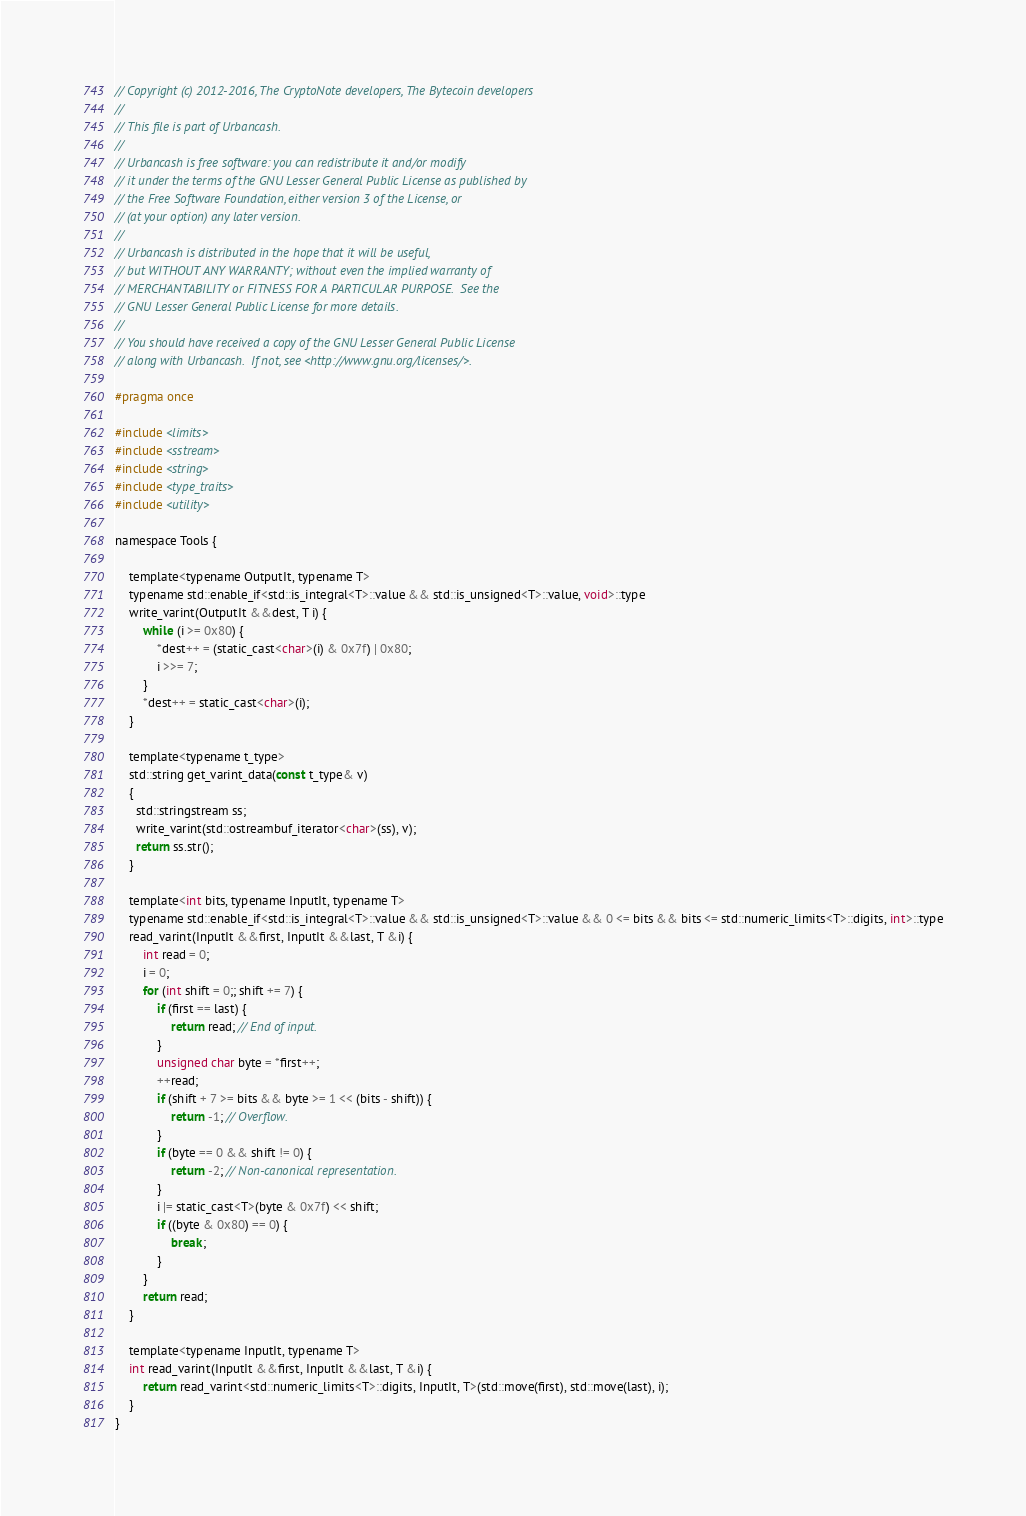Convert code to text. <code><loc_0><loc_0><loc_500><loc_500><_C_>// Copyright (c) 2012-2016, The CryptoNote developers, The Bytecoin developers
//
// This file is part of Urbancash.
//
// Urbancash is free software: you can redistribute it and/or modify
// it under the terms of the GNU Lesser General Public License as published by
// the Free Software Foundation, either version 3 of the License, or
// (at your option) any later version.
//
// Urbancash is distributed in the hope that it will be useful,
// but WITHOUT ANY WARRANTY; without even the implied warranty of
// MERCHANTABILITY or FITNESS FOR A PARTICULAR PURPOSE.  See the
// GNU Lesser General Public License for more details.
//
// You should have received a copy of the GNU Lesser General Public License
// along with Urbancash.  If not, see <http://www.gnu.org/licenses/>.

#pragma once

#include <limits>
#include <sstream>
#include <string>
#include <type_traits>
#include <utility>

namespace Tools {

    template<typename OutputIt, typename T>
    typename std::enable_if<std::is_integral<T>::value && std::is_unsigned<T>::value, void>::type
    write_varint(OutputIt &&dest, T i) {
        while (i >= 0x80) {
            *dest++ = (static_cast<char>(i) & 0x7f) | 0x80;
            i >>= 7;
        }
        *dest++ = static_cast<char>(i);
    }

    template<typename t_type>
    std::string get_varint_data(const t_type& v)
    {
      std::stringstream ss;
      write_varint(std::ostreambuf_iterator<char>(ss), v);
      return ss.str();
    }

    template<int bits, typename InputIt, typename T>
    typename std::enable_if<std::is_integral<T>::value && std::is_unsigned<T>::value && 0 <= bits && bits <= std::numeric_limits<T>::digits, int>::type
    read_varint(InputIt &&first, InputIt &&last, T &i) {
        int read = 0;
        i = 0;
        for (int shift = 0;; shift += 7) {
            if (first == last) {
                return read; // End of input.
            }
            unsigned char byte = *first++;
            ++read;
            if (shift + 7 >= bits && byte >= 1 << (bits - shift)) {
                return -1; // Overflow.
            }
            if (byte == 0 && shift != 0) {
                return -2; // Non-canonical representation.
            }
            i |= static_cast<T>(byte & 0x7f) << shift;
            if ((byte & 0x80) == 0) {
                break;
            }
        }
        return read;
    }

    template<typename InputIt, typename T>
    int read_varint(InputIt &&first, InputIt &&last, T &i) {
        return read_varint<std::numeric_limits<T>::digits, InputIt, T>(std::move(first), std::move(last), i);
    }
}
</code> 